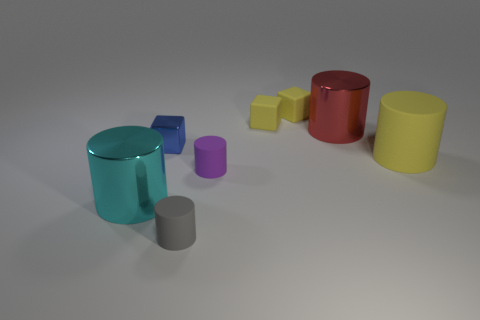Subtract all rubber blocks. How many blocks are left? 1 Add 2 rubber cubes. How many objects exist? 10 Subtract all cyan cylinders. How many cylinders are left? 4 Subtract all cylinders. How many objects are left? 3 Add 2 large cylinders. How many large cylinders are left? 5 Add 8 big blue metal spheres. How many big blue metal spheres exist? 8 Subtract 1 cyan cylinders. How many objects are left? 7 Subtract 1 blocks. How many blocks are left? 2 Subtract all red cylinders. Subtract all gray balls. How many cylinders are left? 4 Subtract all green cylinders. How many yellow cubes are left? 2 